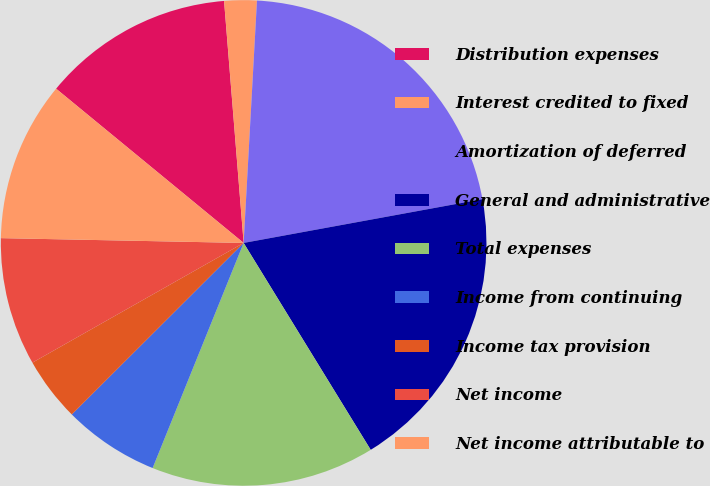<chart> <loc_0><loc_0><loc_500><loc_500><pie_chart><fcel>Distribution expenses<fcel>Interest credited to fixed<fcel>Amortization of deferred<fcel>General and administrative<fcel>Total expenses<fcel>Income from continuing<fcel>Income tax provision<fcel>Net income<fcel>Net income attributable to<nl><fcel>12.76%<fcel>2.16%<fcel>21.24%<fcel>19.12%<fcel>14.88%<fcel>6.4%<fcel>4.28%<fcel>8.52%<fcel>10.64%<nl></chart> 